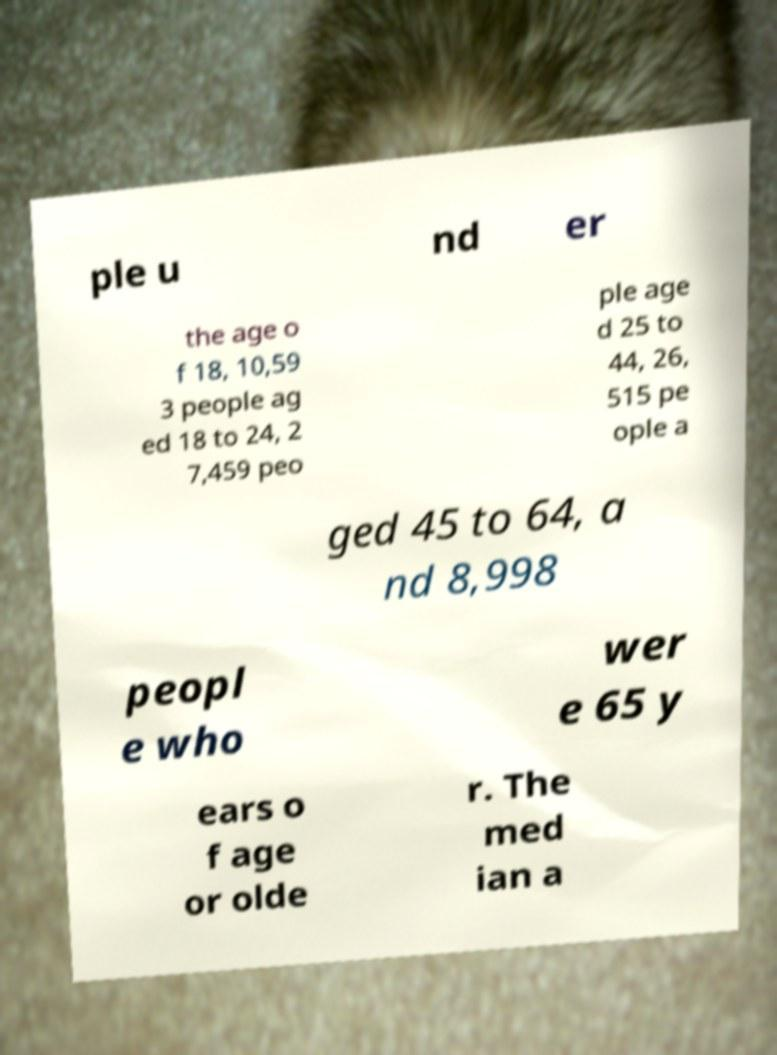There's text embedded in this image that I need extracted. Can you transcribe it verbatim? ple u nd er the age o f 18, 10,59 3 people ag ed 18 to 24, 2 7,459 peo ple age d 25 to 44, 26, 515 pe ople a ged 45 to 64, a nd 8,998 peopl e who wer e 65 y ears o f age or olde r. The med ian a 